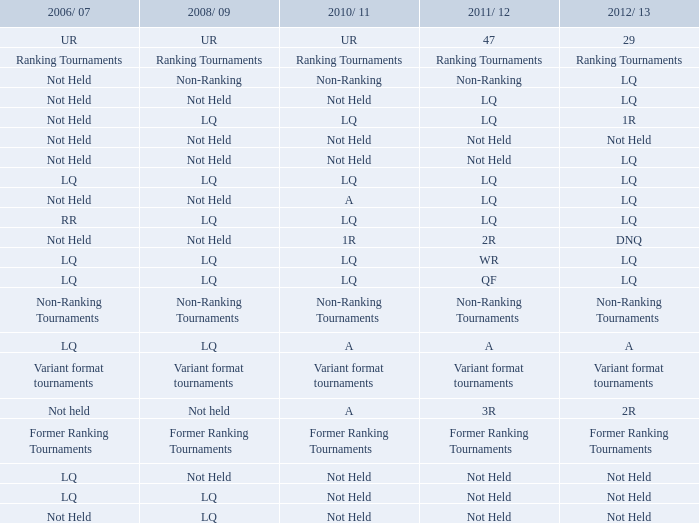What is 2008/09, when 2010/11 is referred to as ur? UR. 